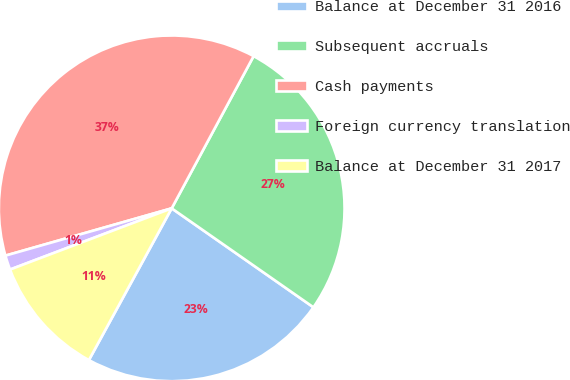Convert chart to OTSL. <chart><loc_0><loc_0><loc_500><loc_500><pie_chart><fcel>Balance at December 31 2016<fcel>Subsequent accruals<fcel>Cash payments<fcel>Foreign currency translation<fcel>Balance at December 31 2017<nl><fcel>23.25%<fcel>26.84%<fcel>37.27%<fcel>1.35%<fcel>11.29%<nl></chart> 